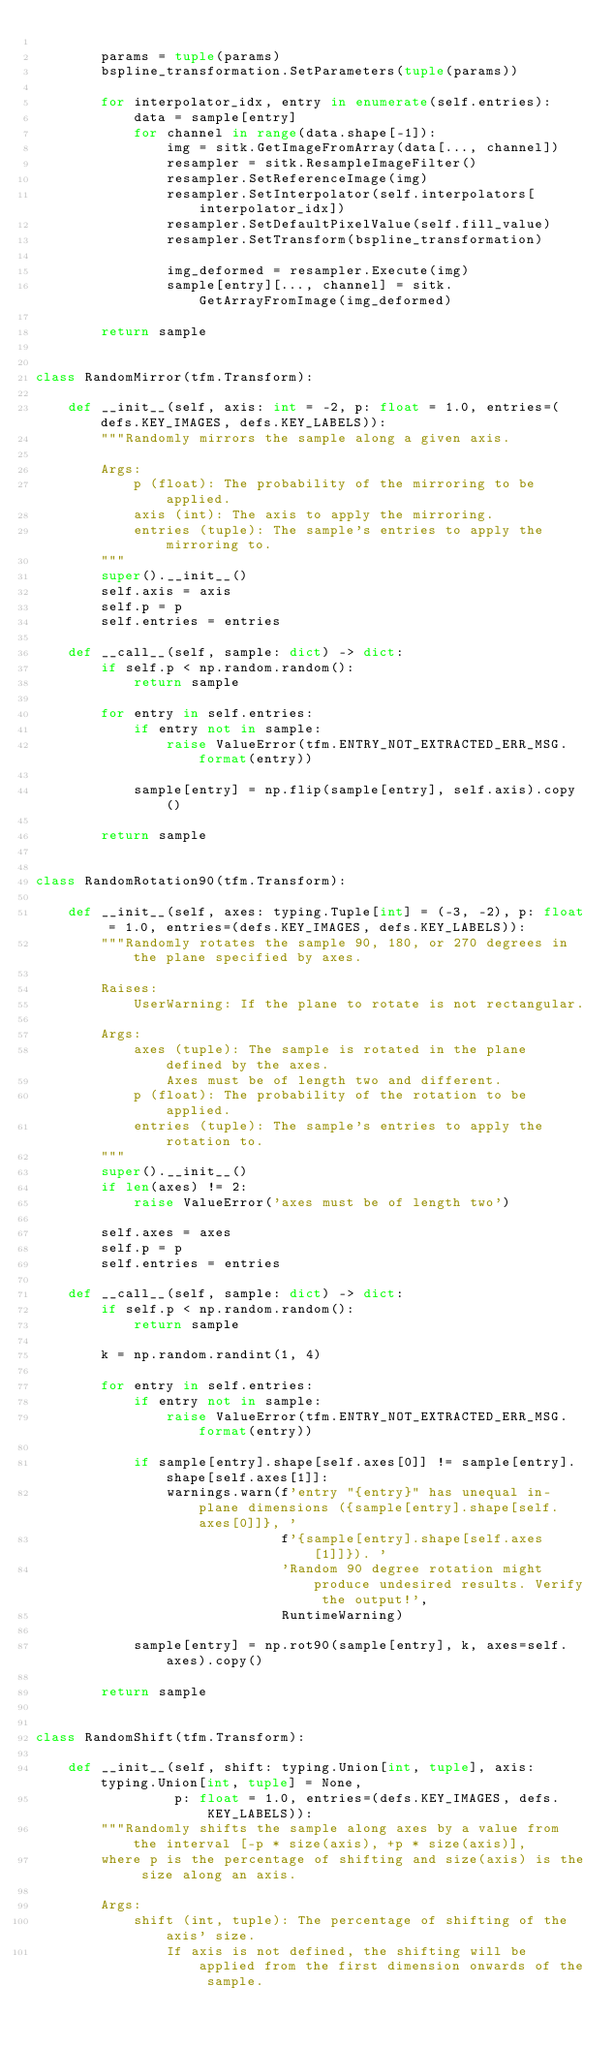Convert code to text. <code><loc_0><loc_0><loc_500><loc_500><_Python_>
        params = tuple(params)
        bspline_transformation.SetParameters(tuple(params))

        for interpolator_idx, entry in enumerate(self.entries):
            data = sample[entry]
            for channel in range(data.shape[-1]):
                img = sitk.GetImageFromArray(data[..., channel])
                resampler = sitk.ResampleImageFilter()
                resampler.SetReferenceImage(img)
                resampler.SetInterpolator(self.interpolators[interpolator_idx])
                resampler.SetDefaultPixelValue(self.fill_value)
                resampler.SetTransform(bspline_transformation)

                img_deformed = resampler.Execute(img)
                sample[entry][..., channel] = sitk.GetArrayFromImage(img_deformed)

        return sample


class RandomMirror(tfm.Transform):

    def __init__(self, axis: int = -2, p: float = 1.0, entries=(defs.KEY_IMAGES, defs.KEY_LABELS)):
        """Randomly mirrors the sample along a given axis.

        Args:
            p (float): The probability of the mirroring to be applied.
            axis (int): The axis to apply the mirroring.
            entries (tuple): The sample's entries to apply the mirroring to.
        """
        super().__init__()
        self.axis = axis
        self.p = p
        self.entries = entries

    def __call__(self, sample: dict) -> dict:
        if self.p < np.random.random():
            return sample

        for entry in self.entries:
            if entry not in sample:
                raise ValueError(tfm.ENTRY_NOT_EXTRACTED_ERR_MSG.format(entry))

            sample[entry] = np.flip(sample[entry], self.axis).copy()

        return sample


class RandomRotation90(tfm.Transform):

    def __init__(self, axes: typing.Tuple[int] = (-3, -2), p: float = 1.0, entries=(defs.KEY_IMAGES, defs.KEY_LABELS)):
        """Randomly rotates the sample 90, 180, or 270 degrees in the plane specified by axes.

        Raises:
            UserWarning: If the plane to rotate is not rectangular.

        Args:
            axes (tuple): The sample is rotated in the plane defined by the axes.
                Axes must be of length two and different.
            p (float): The probability of the rotation to be applied.
            entries (tuple): The sample's entries to apply the rotation to.
        """
        super().__init__()
        if len(axes) != 2:
            raise ValueError('axes must be of length two')

        self.axes = axes
        self.p = p
        self.entries = entries

    def __call__(self, sample: dict) -> dict:
        if self.p < np.random.random():
            return sample

        k = np.random.randint(1, 4)

        for entry in self.entries:
            if entry not in sample:
                raise ValueError(tfm.ENTRY_NOT_EXTRACTED_ERR_MSG.format(entry))

            if sample[entry].shape[self.axes[0]] != sample[entry].shape[self.axes[1]]:
                warnings.warn(f'entry "{entry}" has unequal in-plane dimensions ({sample[entry].shape[self.axes[0]]}, '
                              f'{sample[entry].shape[self.axes[1]]}). '
                              'Random 90 degree rotation might produce undesired results. Verify the output!',
                              RuntimeWarning)

            sample[entry] = np.rot90(sample[entry], k, axes=self.axes).copy()

        return sample


class RandomShift(tfm.Transform):

    def __init__(self, shift: typing.Union[int, tuple], axis: typing.Union[int, tuple] = None,
                 p: float = 1.0, entries=(defs.KEY_IMAGES, defs.KEY_LABELS)):
        """Randomly shifts the sample along axes by a value from the interval [-p * size(axis), +p * size(axis)],
        where p is the percentage of shifting and size(axis) is the size along an axis.

        Args:
            shift (int, tuple): The percentage of shifting of the axis' size.
                If axis is not defined, the shifting will be applied from the first dimension onwards of the sample.</code> 